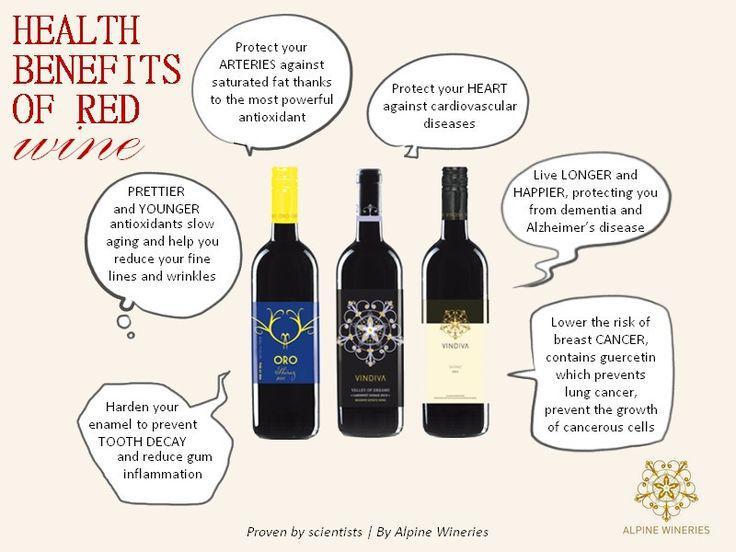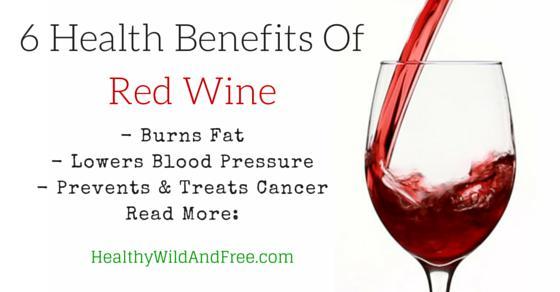The first image is the image on the left, the second image is the image on the right. Examine the images to the left and right. Is the description "Images show a total of three wine bottles." accurate? Answer yes or no. Yes. 